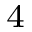Convert formula to latex. <formula><loc_0><loc_0><loc_500><loc_500>^ { 4 }</formula> 